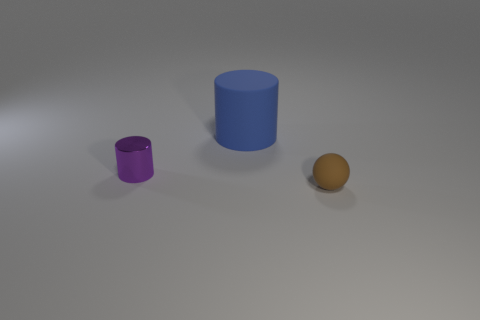Are there any other things that are the same size as the matte cylinder?
Your response must be concise. No. Is the shape of the object that is right of the matte cylinder the same as  the big blue matte object?
Give a very brief answer. No. There is a tiny object that is behind the tiny brown matte thing; what is its material?
Keep it short and to the point. Metal. The brown object that is in front of the cylinder in front of the big rubber thing is what shape?
Provide a short and direct response. Sphere. Is the shape of the big blue thing the same as the tiny thing in front of the tiny purple metal cylinder?
Ensure brevity in your answer.  No. What number of blue matte cylinders are behind the rubber object behind the brown ball?
Offer a terse response. 0. There is another object that is the same shape as the tiny metal object; what is its material?
Provide a short and direct response. Rubber. How many green objects are rubber balls or big objects?
Provide a short and direct response. 0. What color is the thing to the left of the rubber thing that is behind the brown sphere?
Your answer should be very brief. Purple. Is the number of small purple cylinders on the right side of the large matte thing less than the number of large matte cylinders to the left of the tiny brown rubber ball?
Ensure brevity in your answer.  Yes. 